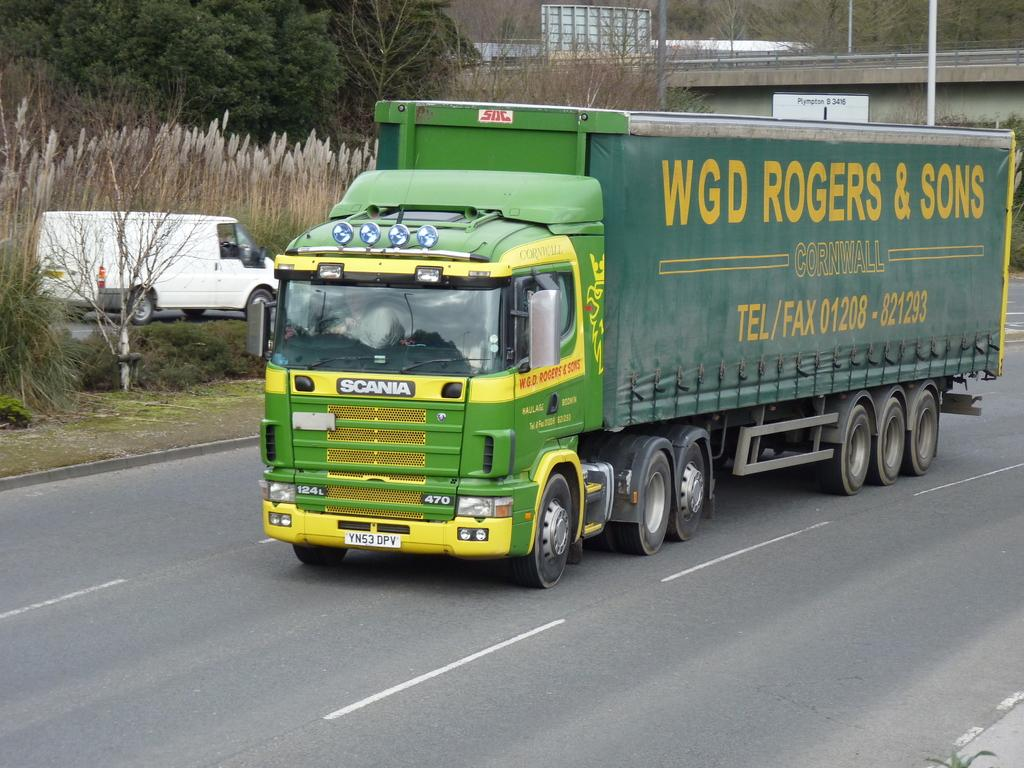What is the main subject in the center of the image? There is a truck in the center of the image. Where is the truck located? The truck is on the road. What other vehicle can be seen in the image? There is a van on the left side of the image. What can be seen in the background of the image? There are trees, a bridge, and poles in the background of the image. What type of waves can be seen crashing against the shore in the image? There are no waves or shore visible in the image; it features a truck, a van, and various background elements. 